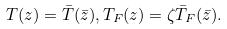Convert formula to latex. <formula><loc_0><loc_0><loc_500><loc_500>T ( z ) = \bar { T } ( \bar { z } ) , T _ { F } ( z ) = \zeta \bar { T } _ { F } ( \bar { z } ) .</formula> 